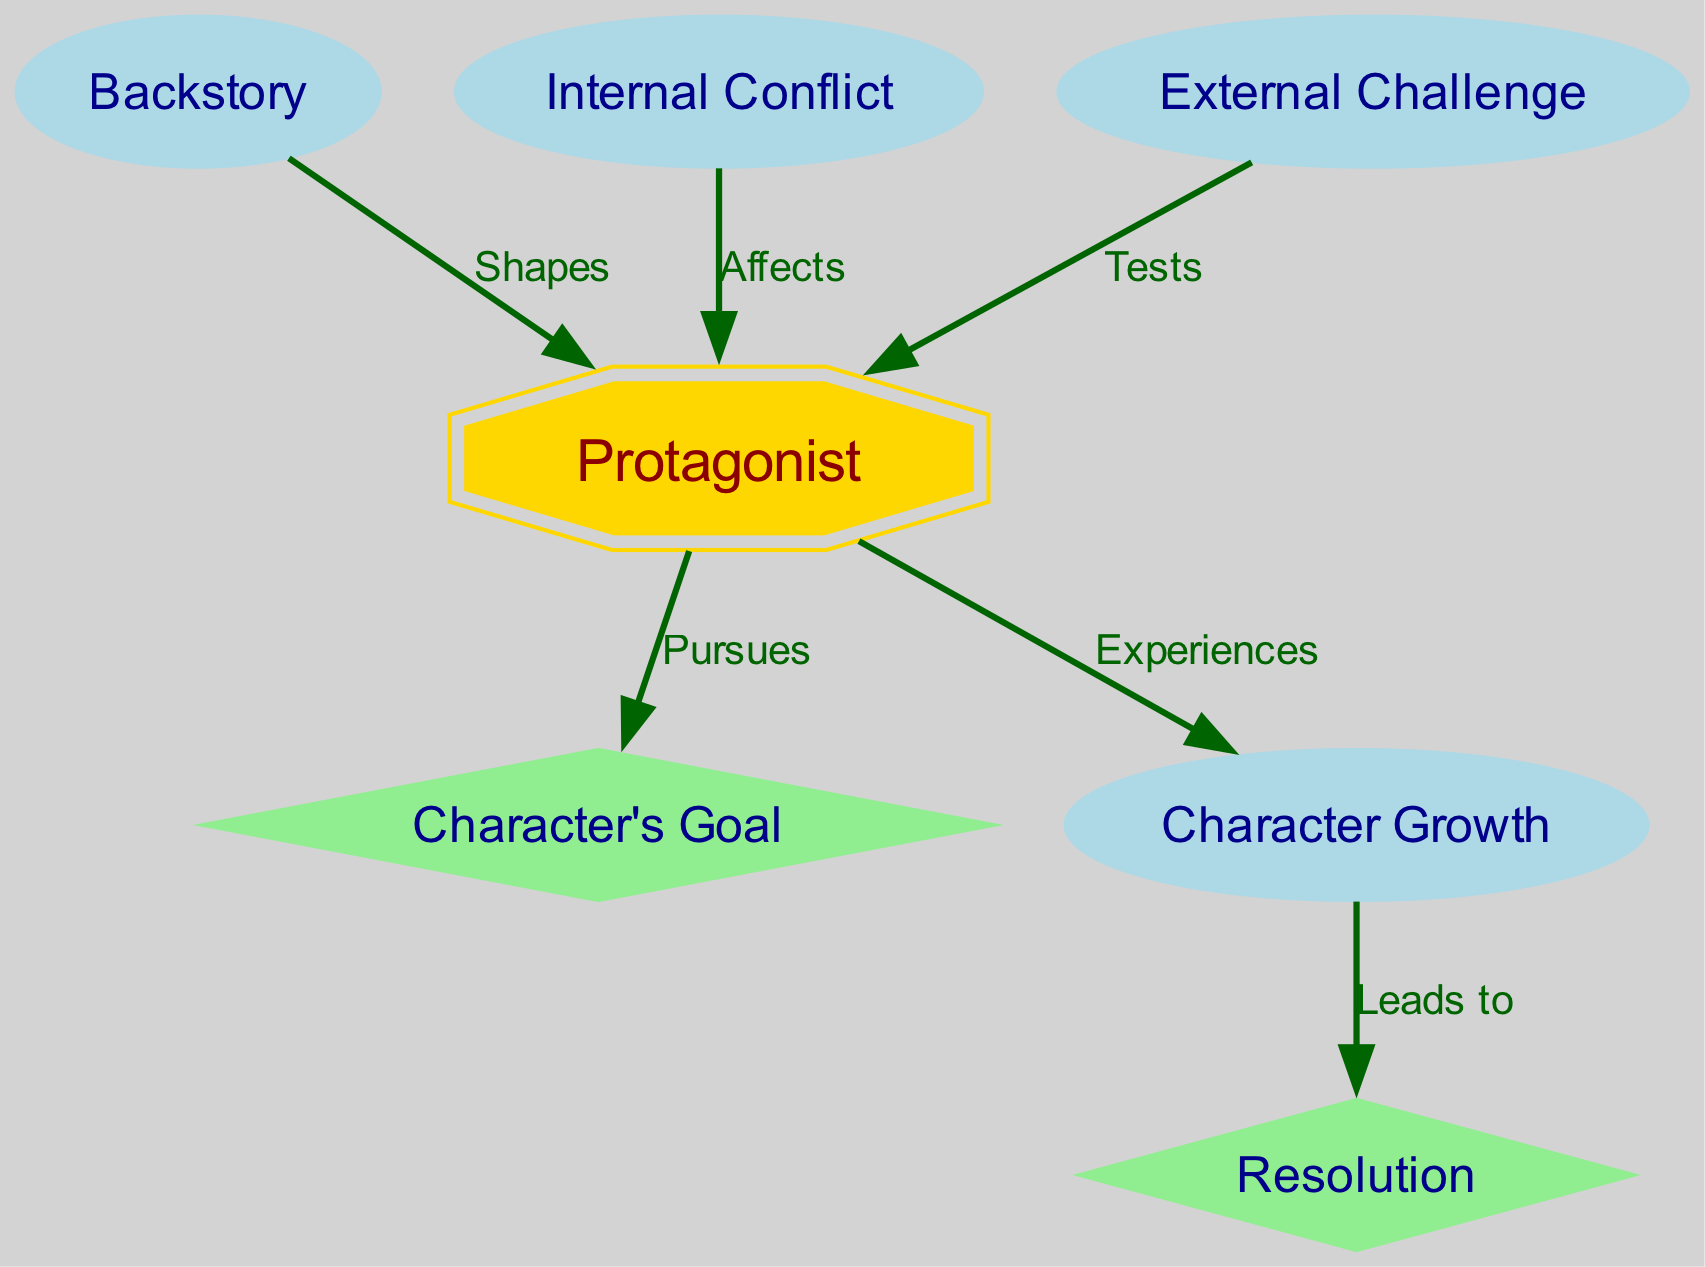What is the label of the starting node? The starting node is "Protagonist," which corresponds to the character of the narrative.
Answer: Protagonist How many nodes are present in the diagram? The diagram includes a total of 7 nodes, each representing different elements of the character arc.
Answer: 7 What are the two nodes connected by the edge labeled "Pursues"? The edge "Pursues" connects the nodes "Protagonist" and "Character's Goal," indicating the protagonist's active pursuit of their goal.
Answer: Protagonist, Character's Goal Which node leads to the "Resolution" node? The node "Character Growth" is linked to the "Resolution" node, suggesting that character growth is essential for achieving resolution.
Answer: Character Growth What relationship does the "Internal Conflict" have with the "Protagonist"? The relationship is indicated by the edge labeled "Affects," which means that internal conflict has a significant impact on the protagonist.
Answer: Affects What is the shape of the "Character's Goal" node? The shape of the "Character's Goal" node is diamond, representing its importance as a critical plot element in the narrative.
Answer: Diamond How does the "External Challenge" relate to the "Protagonist"? The edge connecting them is labeled "Tests," meaning that external challenges serve to test the protagonist in their journey.
Answer: Tests Identify the flow direction from “Character Growth” to “Resolution”. The flow is indicated by the edge labeled “Leads to,” signifying that character growth is a precursor to achieving resolution in the character arc.
Answer: Leads to What node shapes are used for “Protagonist” and “Character's Goal”? The "Protagonist" node is shaped like a double octagon, while the "Character's Goal" node is a diamond, indicating different thematic roles they play.
Answer: Double octagon, diamond 